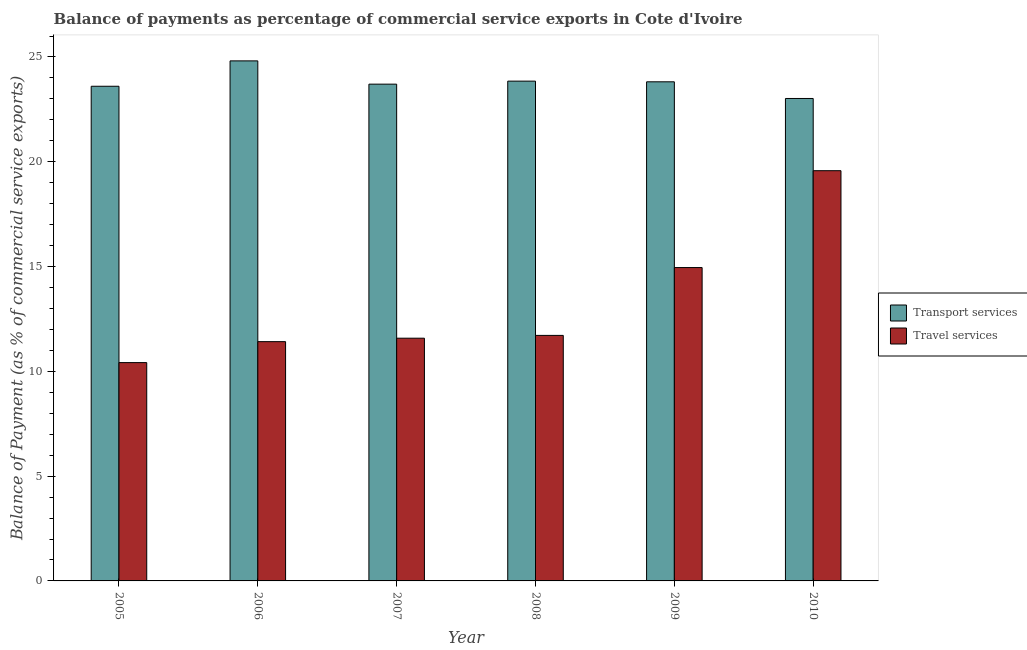Are the number of bars per tick equal to the number of legend labels?
Your response must be concise. Yes. How many bars are there on the 4th tick from the left?
Offer a terse response. 2. What is the balance of payments of travel services in 2007?
Provide a succinct answer. 11.58. Across all years, what is the maximum balance of payments of travel services?
Provide a succinct answer. 19.57. Across all years, what is the minimum balance of payments of travel services?
Offer a very short reply. 10.42. In which year was the balance of payments of travel services maximum?
Your answer should be very brief. 2010. In which year was the balance of payments of travel services minimum?
Offer a very short reply. 2005. What is the total balance of payments of travel services in the graph?
Offer a terse response. 79.66. What is the difference between the balance of payments of transport services in 2007 and that in 2010?
Make the answer very short. 0.68. What is the difference between the balance of payments of transport services in 2005 and the balance of payments of travel services in 2007?
Give a very brief answer. -0.1. What is the average balance of payments of transport services per year?
Offer a terse response. 23.8. In the year 2008, what is the difference between the balance of payments of transport services and balance of payments of travel services?
Give a very brief answer. 0. In how many years, is the balance of payments of transport services greater than 22 %?
Give a very brief answer. 6. What is the ratio of the balance of payments of travel services in 2006 to that in 2009?
Your answer should be compact. 0.76. Is the balance of payments of travel services in 2005 less than that in 2008?
Ensure brevity in your answer.  Yes. Is the difference between the balance of payments of transport services in 2005 and 2006 greater than the difference between the balance of payments of travel services in 2005 and 2006?
Your answer should be compact. No. What is the difference between the highest and the second highest balance of payments of travel services?
Ensure brevity in your answer.  4.62. What is the difference between the highest and the lowest balance of payments of transport services?
Give a very brief answer. 1.79. What does the 1st bar from the left in 2005 represents?
Make the answer very short. Transport services. What does the 2nd bar from the right in 2008 represents?
Provide a succinct answer. Transport services. How many bars are there?
Give a very brief answer. 12. What is the difference between two consecutive major ticks on the Y-axis?
Ensure brevity in your answer.  5. Does the graph contain grids?
Offer a terse response. No. How are the legend labels stacked?
Your answer should be compact. Vertical. What is the title of the graph?
Provide a short and direct response. Balance of payments as percentage of commercial service exports in Cote d'Ivoire. What is the label or title of the X-axis?
Your answer should be compact. Year. What is the label or title of the Y-axis?
Make the answer very short. Balance of Payment (as % of commercial service exports). What is the Balance of Payment (as % of commercial service exports) of Transport services in 2005?
Your response must be concise. 23.6. What is the Balance of Payment (as % of commercial service exports) in Travel services in 2005?
Ensure brevity in your answer.  10.42. What is the Balance of Payment (as % of commercial service exports) in Transport services in 2006?
Keep it short and to the point. 24.81. What is the Balance of Payment (as % of commercial service exports) in Travel services in 2006?
Offer a very short reply. 11.42. What is the Balance of Payment (as % of commercial service exports) in Transport services in 2007?
Your answer should be compact. 23.7. What is the Balance of Payment (as % of commercial service exports) of Travel services in 2007?
Provide a short and direct response. 11.58. What is the Balance of Payment (as % of commercial service exports) of Transport services in 2008?
Ensure brevity in your answer.  23.85. What is the Balance of Payment (as % of commercial service exports) in Travel services in 2008?
Ensure brevity in your answer.  11.72. What is the Balance of Payment (as % of commercial service exports) of Transport services in 2009?
Your answer should be very brief. 23.82. What is the Balance of Payment (as % of commercial service exports) in Travel services in 2009?
Give a very brief answer. 14.95. What is the Balance of Payment (as % of commercial service exports) of Transport services in 2010?
Give a very brief answer. 23.02. What is the Balance of Payment (as % of commercial service exports) in Travel services in 2010?
Offer a very short reply. 19.57. Across all years, what is the maximum Balance of Payment (as % of commercial service exports) in Transport services?
Your response must be concise. 24.81. Across all years, what is the maximum Balance of Payment (as % of commercial service exports) in Travel services?
Ensure brevity in your answer.  19.57. Across all years, what is the minimum Balance of Payment (as % of commercial service exports) of Transport services?
Offer a very short reply. 23.02. Across all years, what is the minimum Balance of Payment (as % of commercial service exports) in Travel services?
Ensure brevity in your answer.  10.42. What is the total Balance of Payment (as % of commercial service exports) of Transport services in the graph?
Give a very brief answer. 142.81. What is the total Balance of Payment (as % of commercial service exports) in Travel services in the graph?
Offer a terse response. 79.66. What is the difference between the Balance of Payment (as % of commercial service exports) of Transport services in 2005 and that in 2006?
Keep it short and to the point. -1.21. What is the difference between the Balance of Payment (as % of commercial service exports) in Transport services in 2005 and that in 2007?
Your answer should be very brief. -0.1. What is the difference between the Balance of Payment (as % of commercial service exports) of Travel services in 2005 and that in 2007?
Keep it short and to the point. -1.16. What is the difference between the Balance of Payment (as % of commercial service exports) in Transport services in 2005 and that in 2008?
Give a very brief answer. -0.24. What is the difference between the Balance of Payment (as % of commercial service exports) in Travel services in 2005 and that in 2008?
Keep it short and to the point. -1.3. What is the difference between the Balance of Payment (as % of commercial service exports) in Transport services in 2005 and that in 2009?
Your answer should be very brief. -0.21. What is the difference between the Balance of Payment (as % of commercial service exports) in Travel services in 2005 and that in 2009?
Provide a short and direct response. -4.54. What is the difference between the Balance of Payment (as % of commercial service exports) of Transport services in 2005 and that in 2010?
Offer a terse response. 0.58. What is the difference between the Balance of Payment (as % of commercial service exports) in Travel services in 2005 and that in 2010?
Offer a terse response. -9.16. What is the difference between the Balance of Payment (as % of commercial service exports) in Transport services in 2006 and that in 2007?
Provide a succinct answer. 1.11. What is the difference between the Balance of Payment (as % of commercial service exports) in Travel services in 2006 and that in 2007?
Offer a very short reply. -0.17. What is the difference between the Balance of Payment (as % of commercial service exports) in Transport services in 2006 and that in 2008?
Make the answer very short. 0.97. What is the difference between the Balance of Payment (as % of commercial service exports) of Travel services in 2006 and that in 2008?
Offer a very short reply. -0.3. What is the difference between the Balance of Payment (as % of commercial service exports) in Travel services in 2006 and that in 2009?
Provide a succinct answer. -3.54. What is the difference between the Balance of Payment (as % of commercial service exports) of Transport services in 2006 and that in 2010?
Your answer should be compact. 1.79. What is the difference between the Balance of Payment (as % of commercial service exports) in Travel services in 2006 and that in 2010?
Give a very brief answer. -8.16. What is the difference between the Balance of Payment (as % of commercial service exports) in Transport services in 2007 and that in 2008?
Provide a short and direct response. -0.14. What is the difference between the Balance of Payment (as % of commercial service exports) of Travel services in 2007 and that in 2008?
Provide a short and direct response. -0.13. What is the difference between the Balance of Payment (as % of commercial service exports) in Transport services in 2007 and that in 2009?
Your answer should be compact. -0.11. What is the difference between the Balance of Payment (as % of commercial service exports) in Travel services in 2007 and that in 2009?
Your answer should be very brief. -3.37. What is the difference between the Balance of Payment (as % of commercial service exports) in Transport services in 2007 and that in 2010?
Ensure brevity in your answer.  0.68. What is the difference between the Balance of Payment (as % of commercial service exports) of Travel services in 2007 and that in 2010?
Give a very brief answer. -7.99. What is the difference between the Balance of Payment (as % of commercial service exports) of Transport services in 2008 and that in 2009?
Offer a very short reply. 0.03. What is the difference between the Balance of Payment (as % of commercial service exports) of Travel services in 2008 and that in 2009?
Your answer should be compact. -3.24. What is the difference between the Balance of Payment (as % of commercial service exports) of Transport services in 2008 and that in 2010?
Offer a very short reply. 0.83. What is the difference between the Balance of Payment (as % of commercial service exports) of Travel services in 2008 and that in 2010?
Keep it short and to the point. -7.86. What is the difference between the Balance of Payment (as % of commercial service exports) in Transport services in 2009 and that in 2010?
Provide a succinct answer. 0.79. What is the difference between the Balance of Payment (as % of commercial service exports) of Travel services in 2009 and that in 2010?
Offer a very short reply. -4.62. What is the difference between the Balance of Payment (as % of commercial service exports) in Transport services in 2005 and the Balance of Payment (as % of commercial service exports) in Travel services in 2006?
Give a very brief answer. 12.19. What is the difference between the Balance of Payment (as % of commercial service exports) of Transport services in 2005 and the Balance of Payment (as % of commercial service exports) of Travel services in 2007?
Provide a succinct answer. 12.02. What is the difference between the Balance of Payment (as % of commercial service exports) in Transport services in 2005 and the Balance of Payment (as % of commercial service exports) in Travel services in 2008?
Make the answer very short. 11.89. What is the difference between the Balance of Payment (as % of commercial service exports) of Transport services in 2005 and the Balance of Payment (as % of commercial service exports) of Travel services in 2009?
Offer a very short reply. 8.65. What is the difference between the Balance of Payment (as % of commercial service exports) of Transport services in 2005 and the Balance of Payment (as % of commercial service exports) of Travel services in 2010?
Your answer should be very brief. 4.03. What is the difference between the Balance of Payment (as % of commercial service exports) of Transport services in 2006 and the Balance of Payment (as % of commercial service exports) of Travel services in 2007?
Make the answer very short. 13.23. What is the difference between the Balance of Payment (as % of commercial service exports) in Transport services in 2006 and the Balance of Payment (as % of commercial service exports) in Travel services in 2008?
Your answer should be compact. 13.1. What is the difference between the Balance of Payment (as % of commercial service exports) of Transport services in 2006 and the Balance of Payment (as % of commercial service exports) of Travel services in 2009?
Keep it short and to the point. 9.86. What is the difference between the Balance of Payment (as % of commercial service exports) of Transport services in 2006 and the Balance of Payment (as % of commercial service exports) of Travel services in 2010?
Your response must be concise. 5.24. What is the difference between the Balance of Payment (as % of commercial service exports) in Transport services in 2007 and the Balance of Payment (as % of commercial service exports) in Travel services in 2008?
Your answer should be compact. 11.99. What is the difference between the Balance of Payment (as % of commercial service exports) in Transport services in 2007 and the Balance of Payment (as % of commercial service exports) in Travel services in 2009?
Your response must be concise. 8.75. What is the difference between the Balance of Payment (as % of commercial service exports) in Transport services in 2007 and the Balance of Payment (as % of commercial service exports) in Travel services in 2010?
Give a very brief answer. 4.13. What is the difference between the Balance of Payment (as % of commercial service exports) in Transport services in 2008 and the Balance of Payment (as % of commercial service exports) in Travel services in 2009?
Ensure brevity in your answer.  8.9. What is the difference between the Balance of Payment (as % of commercial service exports) in Transport services in 2008 and the Balance of Payment (as % of commercial service exports) in Travel services in 2010?
Ensure brevity in your answer.  4.27. What is the difference between the Balance of Payment (as % of commercial service exports) of Transport services in 2009 and the Balance of Payment (as % of commercial service exports) of Travel services in 2010?
Offer a terse response. 4.24. What is the average Balance of Payment (as % of commercial service exports) of Transport services per year?
Give a very brief answer. 23.8. What is the average Balance of Payment (as % of commercial service exports) in Travel services per year?
Ensure brevity in your answer.  13.28. In the year 2005, what is the difference between the Balance of Payment (as % of commercial service exports) in Transport services and Balance of Payment (as % of commercial service exports) in Travel services?
Provide a succinct answer. 13.19. In the year 2006, what is the difference between the Balance of Payment (as % of commercial service exports) of Transport services and Balance of Payment (as % of commercial service exports) of Travel services?
Make the answer very short. 13.4. In the year 2007, what is the difference between the Balance of Payment (as % of commercial service exports) of Transport services and Balance of Payment (as % of commercial service exports) of Travel services?
Provide a succinct answer. 12.12. In the year 2008, what is the difference between the Balance of Payment (as % of commercial service exports) in Transport services and Balance of Payment (as % of commercial service exports) in Travel services?
Give a very brief answer. 12.13. In the year 2009, what is the difference between the Balance of Payment (as % of commercial service exports) in Transport services and Balance of Payment (as % of commercial service exports) in Travel services?
Offer a very short reply. 8.86. In the year 2010, what is the difference between the Balance of Payment (as % of commercial service exports) in Transport services and Balance of Payment (as % of commercial service exports) in Travel services?
Your response must be concise. 3.45. What is the ratio of the Balance of Payment (as % of commercial service exports) in Transport services in 2005 to that in 2006?
Ensure brevity in your answer.  0.95. What is the ratio of the Balance of Payment (as % of commercial service exports) of Travel services in 2005 to that in 2006?
Ensure brevity in your answer.  0.91. What is the ratio of the Balance of Payment (as % of commercial service exports) of Travel services in 2005 to that in 2007?
Provide a succinct answer. 0.9. What is the ratio of the Balance of Payment (as % of commercial service exports) in Travel services in 2005 to that in 2008?
Offer a terse response. 0.89. What is the ratio of the Balance of Payment (as % of commercial service exports) in Transport services in 2005 to that in 2009?
Ensure brevity in your answer.  0.99. What is the ratio of the Balance of Payment (as % of commercial service exports) of Travel services in 2005 to that in 2009?
Ensure brevity in your answer.  0.7. What is the ratio of the Balance of Payment (as % of commercial service exports) of Transport services in 2005 to that in 2010?
Your answer should be compact. 1.03. What is the ratio of the Balance of Payment (as % of commercial service exports) of Travel services in 2005 to that in 2010?
Offer a terse response. 0.53. What is the ratio of the Balance of Payment (as % of commercial service exports) of Transport services in 2006 to that in 2007?
Ensure brevity in your answer.  1.05. What is the ratio of the Balance of Payment (as % of commercial service exports) of Travel services in 2006 to that in 2007?
Keep it short and to the point. 0.99. What is the ratio of the Balance of Payment (as % of commercial service exports) in Transport services in 2006 to that in 2008?
Keep it short and to the point. 1.04. What is the ratio of the Balance of Payment (as % of commercial service exports) in Travel services in 2006 to that in 2008?
Keep it short and to the point. 0.97. What is the ratio of the Balance of Payment (as % of commercial service exports) in Transport services in 2006 to that in 2009?
Offer a terse response. 1.04. What is the ratio of the Balance of Payment (as % of commercial service exports) of Travel services in 2006 to that in 2009?
Your response must be concise. 0.76. What is the ratio of the Balance of Payment (as % of commercial service exports) of Transport services in 2006 to that in 2010?
Your answer should be very brief. 1.08. What is the ratio of the Balance of Payment (as % of commercial service exports) of Travel services in 2006 to that in 2010?
Your answer should be very brief. 0.58. What is the ratio of the Balance of Payment (as % of commercial service exports) in Transport services in 2007 to that in 2008?
Provide a succinct answer. 0.99. What is the ratio of the Balance of Payment (as % of commercial service exports) of Travel services in 2007 to that in 2008?
Provide a short and direct response. 0.99. What is the ratio of the Balance of Payment (as % of commercial service exports) of Travel services in 2007 to that in 2009?
Your answer should be compact. 0.77. What is the ratio of the Balance of Payment (as % of commercial service exports) of Transport services in 2007 to that in 2010?
Give a very brief answer. 1.03. What is the ratio of the Balance of Payment (as % of commercial service exports) of Travel services in 2007 to that in 2010?
Your response must be concise. 0.59. What is the ratio of the Balance of Payment (as % of commercial service exports) of Transport services in 2008 to that in 2009?
Ensure brevity in your answer.  1. What is the ratio of the Balance of Payment (as % of commercial service exports) of Travel services in 2008 to that in 2009?
Your response must be concise. 0.78. What is the ratio of the Balance of Payment (as % of commercial service exports) of Transport services in 2008 to that in 2010?
Your response must be concise. 1.04. What is the ratio of the Balance of Payment (as % of commercial service exports) in Travel services in 2008 to that in 2010?
Your answer should be compact. 0.6. What is the ratio of the Balance of Payment (as % of commercial service exports) of Transport services in 2009 to that in 2010?
Provide a short and direct response. 1.03. What is the ratio of the Balance of Payment (as % of commercial service exports) of Travel services in 2009 to that in 2010?
Provide a succinct answer. 0.76. What is the difference between the highest and the second highest Balance of Payment (as % of commercial service exports) in Transport services?
Ensure brevity in your answer.  0.97. What is the difference between the highest and the second highest Balance of Payment (as % of commercial service exports) of Travel services?
Provide a short and direct response. 4.62. What is the difference between the highest and the lowest Balance of Payment (as % of commercial service exports) of Transport services?
Make the answer very short. 1.79. What is the difference between the highest and the lowest Balance of Payment (as % of commercial service exports) of Travel services?
Provide a short and direct response. 9.16. 